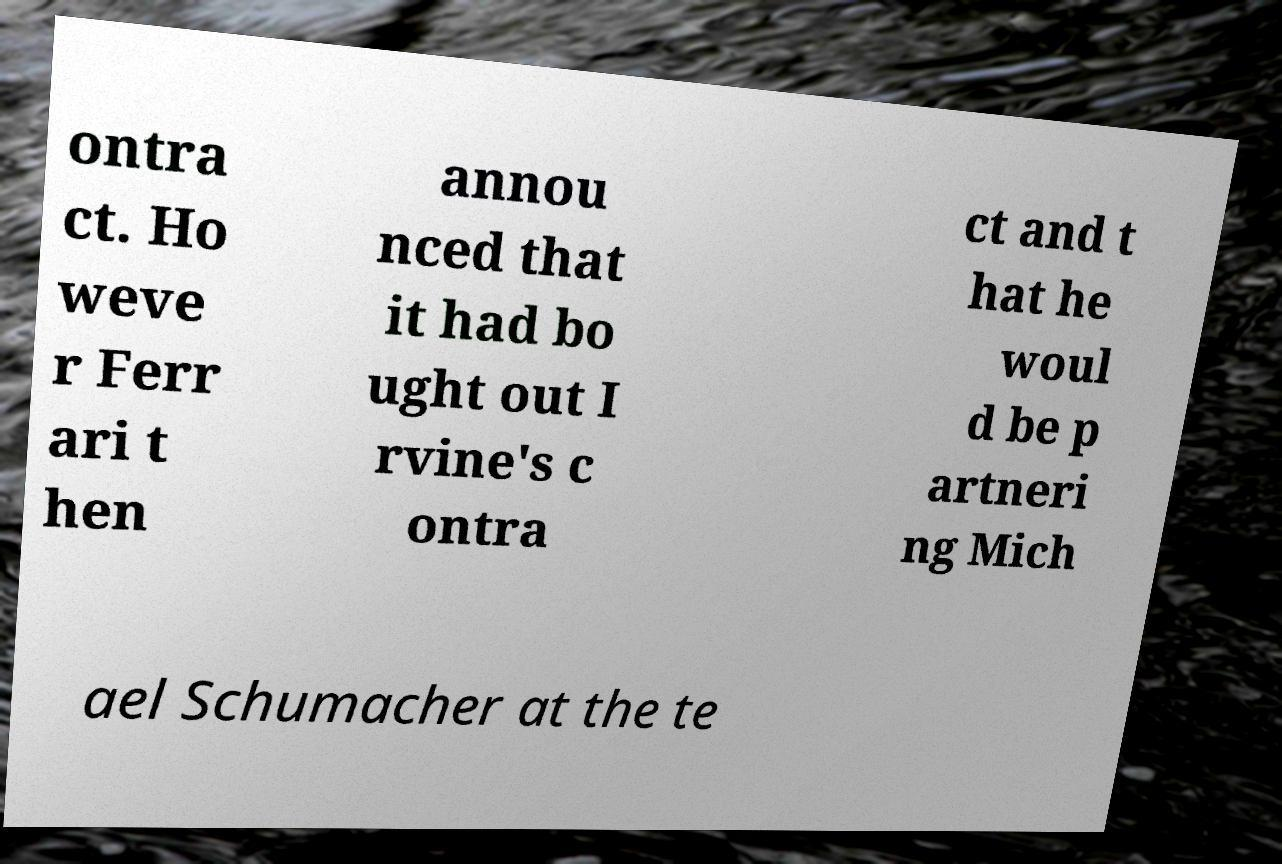There's text embedded in this image that I need extracted. Can you transcribe it verbatim? ontra ct. Ho weve r Ferr ari t hen annou nced that it had bo ught out I rvine's c ontra ct and t hat he woul d be p artneri ng Mich ael Schumacher at the te 